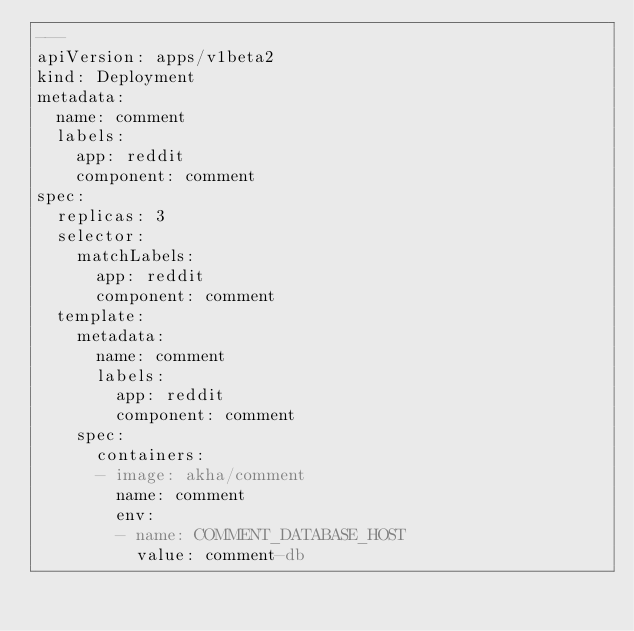Convert code to text. <code><loc_0><loc_0><loc_500><loc_500><_YAML_>---
apiVersion: apps/v1beta2
kind: Deployment
metadata:
  name: comment
  labels:
    app: reddit
    component: comment
spec:
  replicas: 3
  selector:
    matchLabels:
      app: reddit
      component: comment
  template:
    metadata:
      name: comment
      labels:
        app: reddit
        component: comment
    spec:
      containers:
      - image: akha/comment
        name: comment
        env:
        - name: COMMENT_DATABASE_HOST
          value: comment-db
  
</code> 